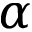<formula> <loc_0><loc_0><loc_500><loc_500>\alpha</formula> 